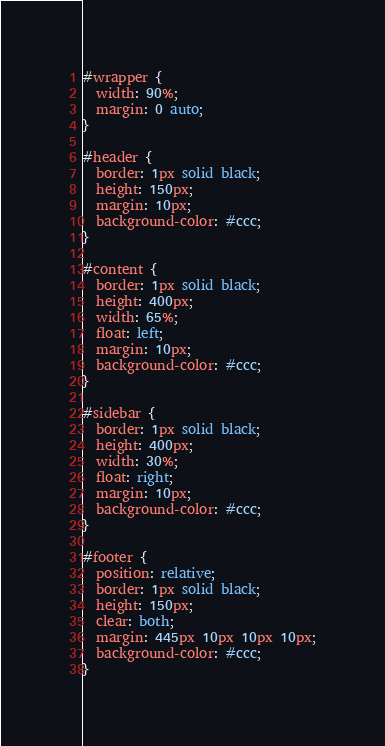<code> <loc_0><loc_0><loc_500><loc_500><_CSS_>#wrapper {
  width: 90%;
  margin: 0 auto;
}

#header {
  border: 1px solid black;
  height: 150px;
  margin: 10px;
  background-color: #ccc;
}

#content {
  border: 1px solid black;
  height: 400px;
  width: 65%;
  float: left;
  margin: 10px;
  background-color: #ccc;
}

#sidebar {
  border: 1px solid black;
  height: 400px;
  width: 30%;
  float: right;
  margin: 10px;
  background-color: #ccc;
}

#footer {
  position: relative;
  border: 1px solid black;
  height: 150px;
  clear: both;
  margin: 445px 10px 10px 10px;
  background-color: #ccc;
}
</code> 